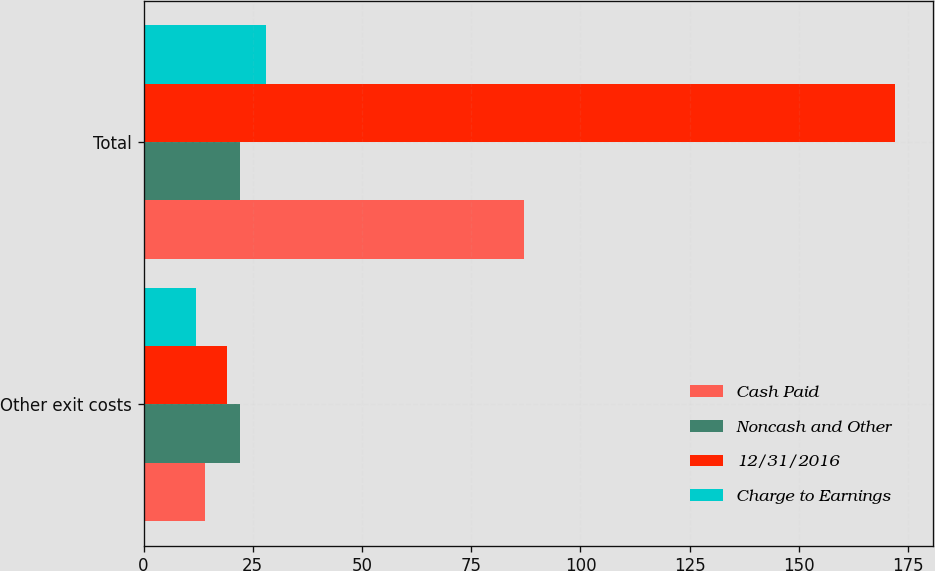<chart> <loc_0><loc_0><loc_500><loc_500><stacked_bar_chart><ecel><fcel>Other exit costs<fcel>Total<nl><fcel>Cash Paid<fcel>14<fcel>87<nl><fcel>Noncash and Other<fcel>22<fcel>22<nl><fcel>12/31/2016<fcel>19<fcel>172<nl><fcel>Charge to Earnings<fcel>12<fcel>28<nl></chart> 